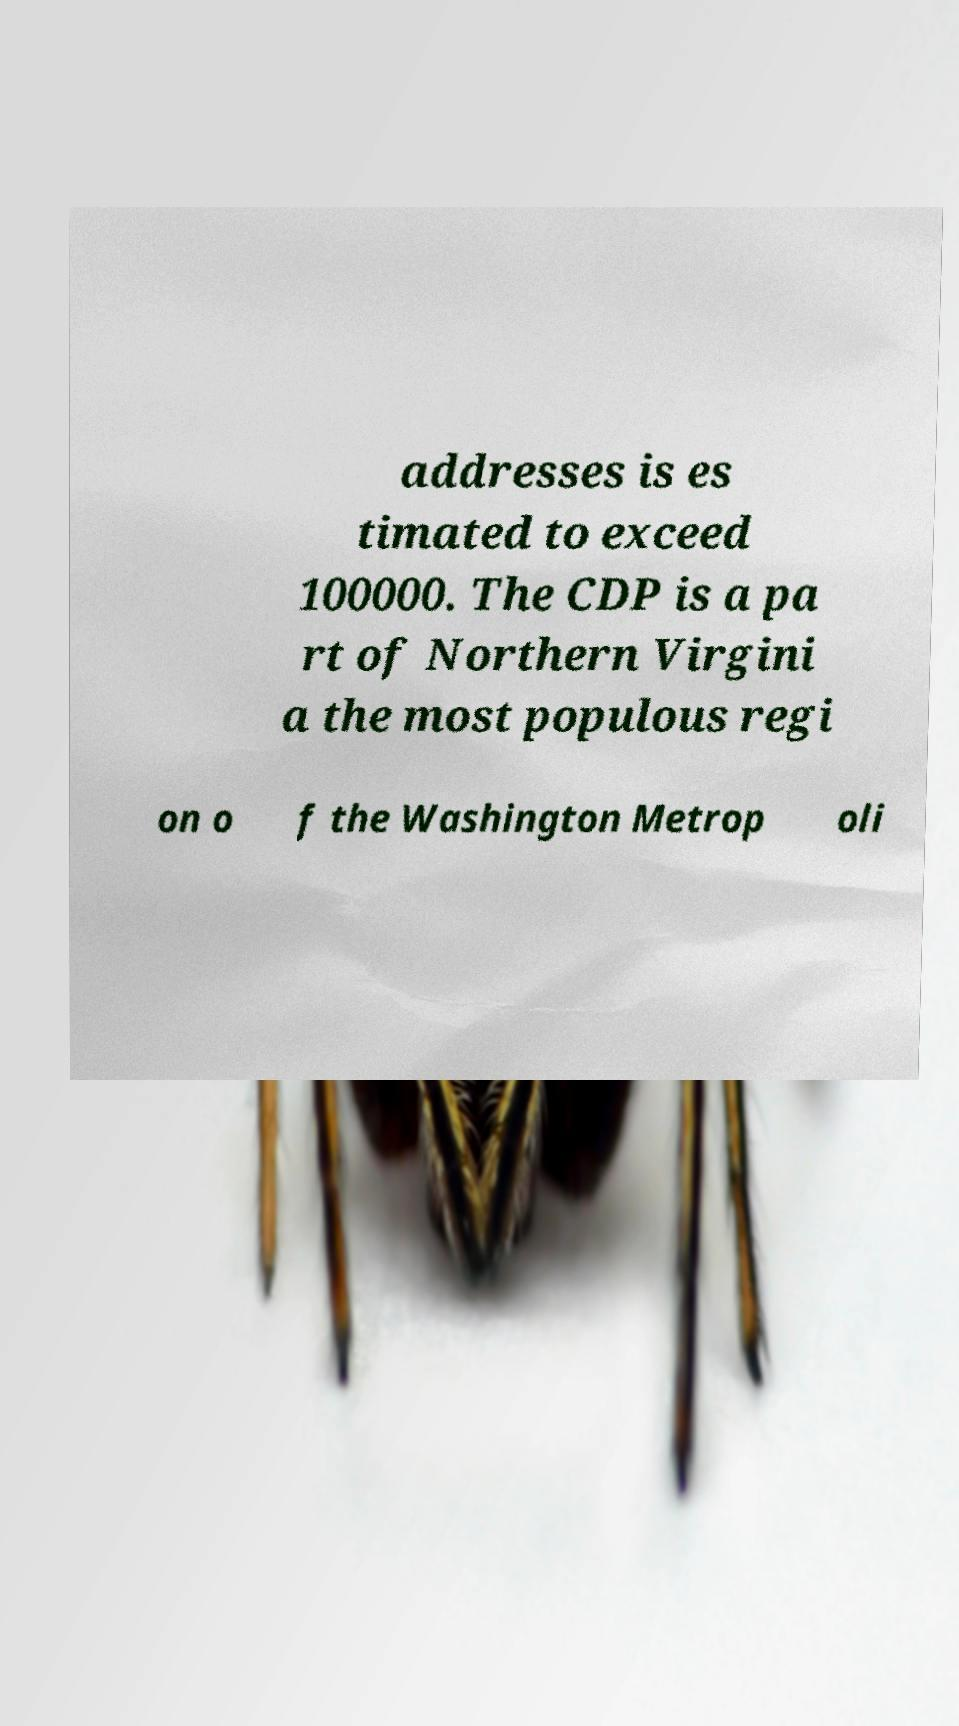Can you accurately transcribe the text from the provided image for me? addresses is es timated to exceed 100000. The CDP is a pa rt of Northern Virgini a the most populous regi on o f the Washington Metrop oli 